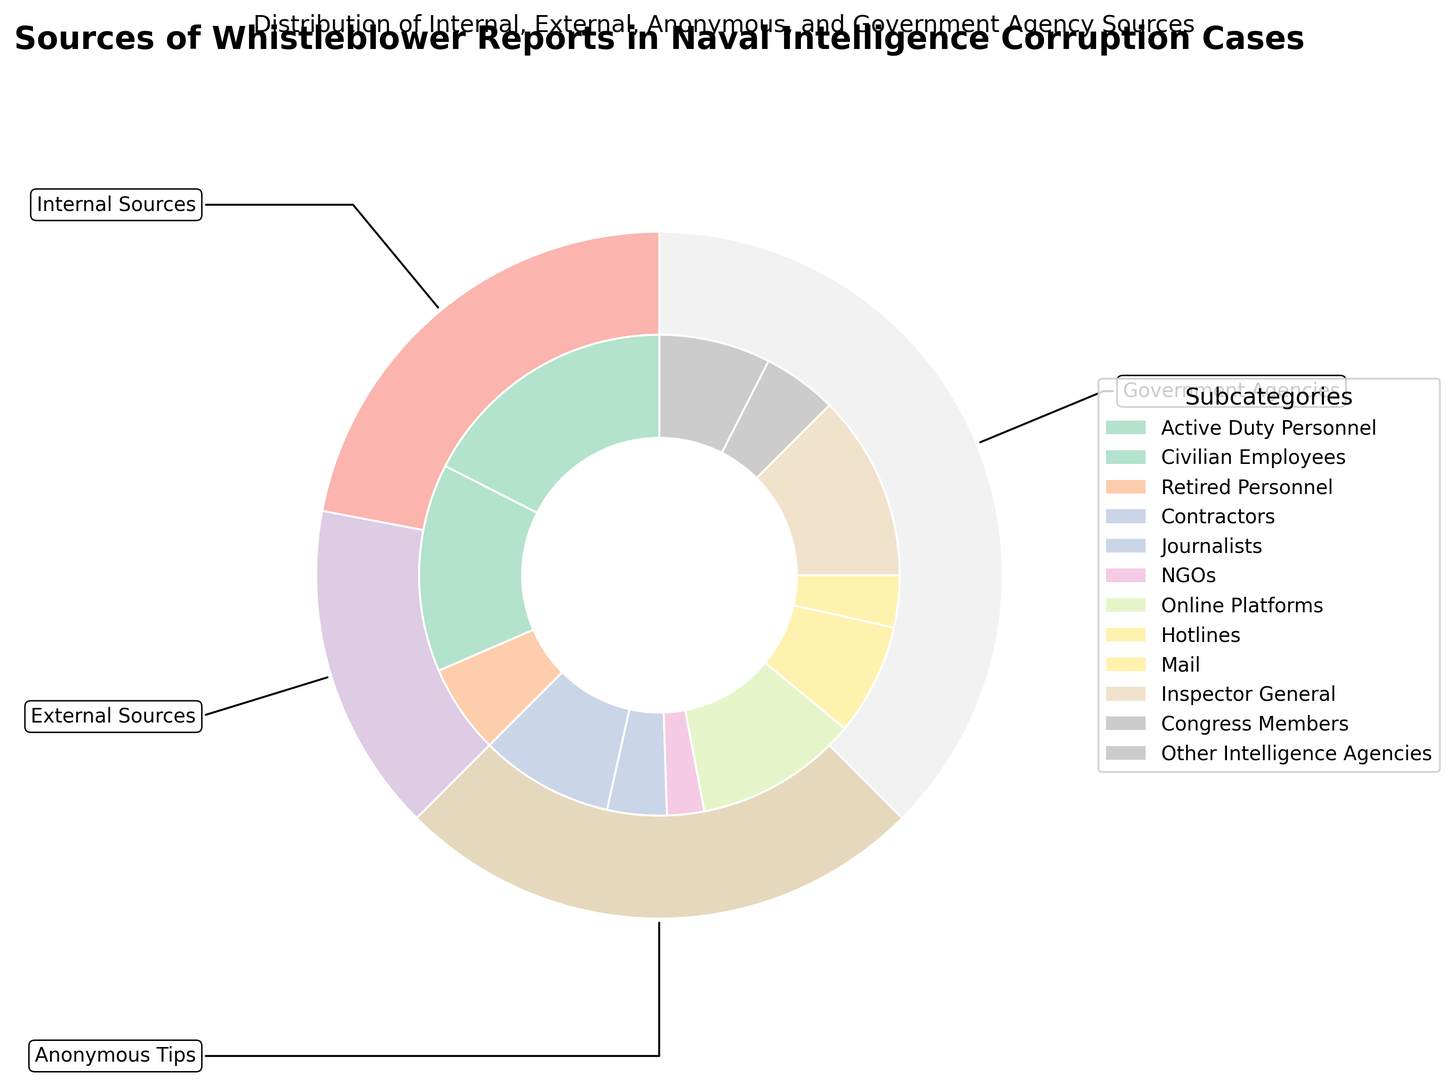What category has the highest number of whistleblower reports? By visually inspecting the outer ring, the "Internal Sources" category has the largest segment.
Answer: Internal Sources Between "Active Duty Personnel" and "Anonymous Tips from Online Platforms", which subcategory has more reports? Comparing the sizes of the segments for these two subcategories reveals that "Active Duty Personnel" has more reports than "Anonymous Tips from Online Platforms".
Answer: Active Duty Personnel What is the total number of reports from government agencies? The subcategories under "Government Agencies" are "Inspector General", "Congress Members", and "Other Intelligence Agencies". Summing their values gives us 25 + 10 + 15.
Answer: 50 Are the reports from civilian employees higher than those from contractors? Looking at the segments, the value for "Civilian Employees" is 28 and for "Contractors" is 18. Since 28 is greater than 18, the reports from civilian employees are higher.
Answer: Yes How do reports from NGOs compare to those from mail under anonymous tips? The segment for NGOs shows a value of 5, while the segment for Mail shows a value of 7. Mail has more reports than NGOs.
Answer: Mail What is the combined number of reports from contractors and journalists? Add the values for "Contractors" and "Journalists", which are 18 and 8 respectively. 18 + 8 = 26.
Answer: 26 Which government agency subcategory contributes the most to whistleblower reports? By comparing the sizes of the subcategories under "Government Agencies", "Inspector General" has the largest segment.
Answer: Inspector General What percentage of internal reports were made by retired personnel? Internal reports are 35 (Active Duty Personnel) + 28 (Civilian Employees) + 12 (Retired Personnel), which totals to 75. Retired Personnel reports are 12 out of 75. The percentage is (12/75) * 100.
Answer: 16% Is the number of reports from online platforms under anonymous tips more or less than those from hotlines and mail combined? "Anonymous Tips" from Online Platforms is 22, while Hotlines is 15 and Mail is 7. Add Hotlines and Mail: 15 + 7 = 22. Since both are equal, the reports from Online Platforms are neither more nor less but equal to the combined Hotlines and Mail.
Answer: Equal How does the total number of external sources compare to the total number of anonymous tips? Sum up the values for External Sources which are "Contractors", "Journalists", and "NGOs". 18 + 8 + 5 = 31. Sum up the values for Anonymous Tips, "Online Platforms", "Hotlines", and "Mail". 22 + 15 + 7 = 44. Comparing 31 to 44, there are fewer external sources than anonymous tips.
Answer: Fewer 